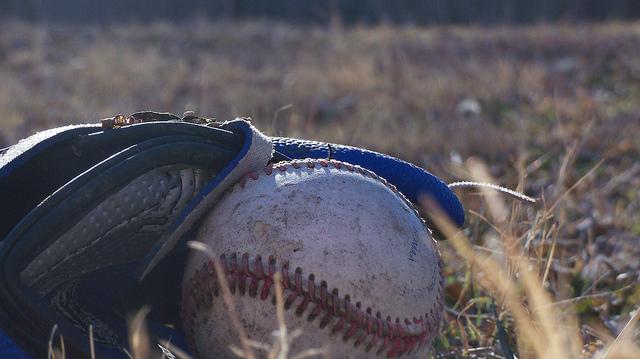Is someone holding the ball?
Concise answer only. No. Is the ball being thrown?
Give a very brief answer. No. What is on the ground?
Keep it brief. Baseball. 